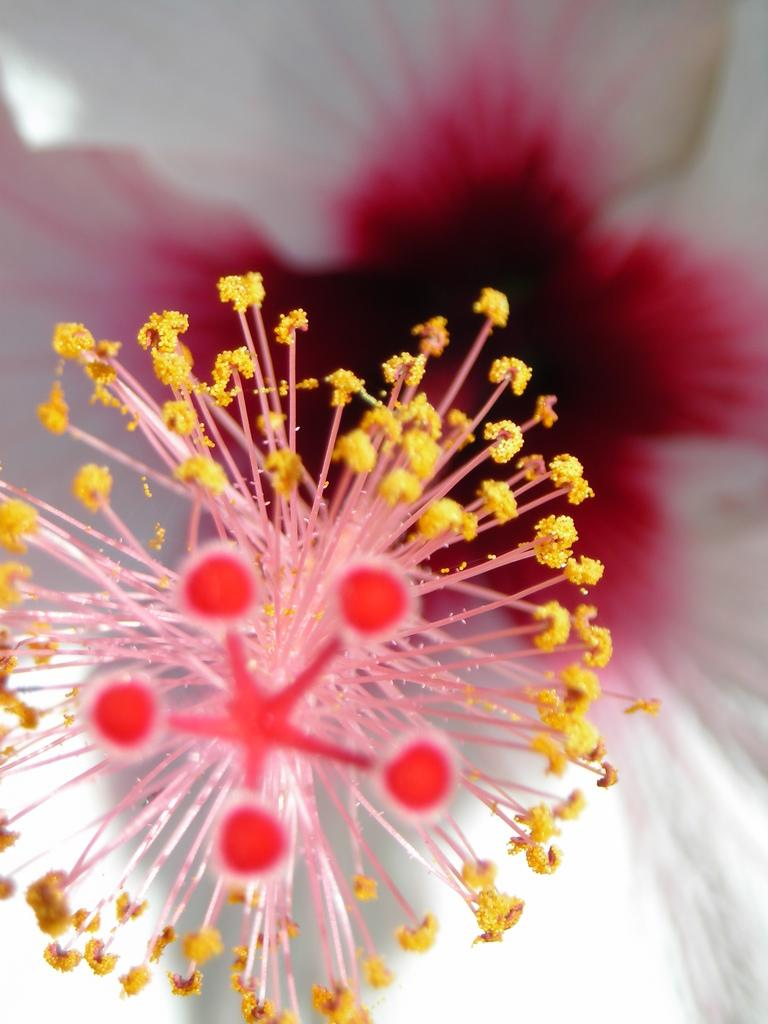What is the main subject of the image? The main subject of the image is a flower. What can be found on the flower? The flower has pollen grains. What colors are the petals of the flower? The petals of the flower are in white and red colors. What type of bone is visible in the image? There is no bone present in the image; it features a flower with pollen grains and petals in white and red colors. 